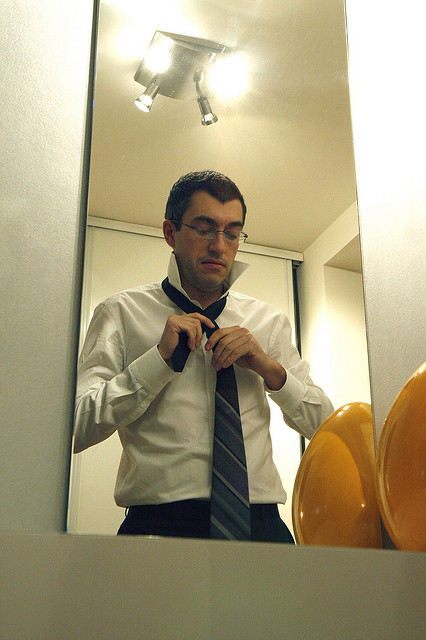Where is the necktie located in relation to the man's shirt? The necktie is positioned in the center of the man's shirt, draping around his neck and being carefully adjusted in front of the mirror. Its placement and adjustment are central to his grooming process. 